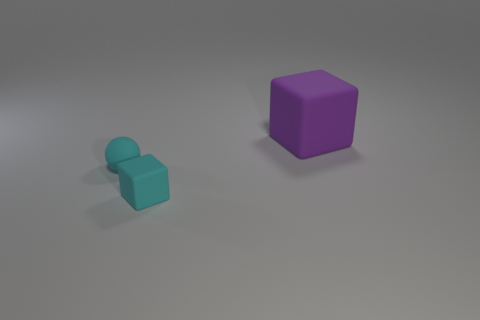There is a tiny cyan object that is the same shape as the purple rubber thing; what is it made of?
Make the answer very short. Rubber. There is a object that is the same color as the small cube; what material is it?
Offer a terse response. Rubber. Is the number of tiny cyan rubber balls less than the number of things?
Make the answer very short. Yes. Do the tiny rubber object that is to the left of the small cyan matte block and the tiny block have the same color?
Provide a succinct answer. Yes. What color is the ball that is the same material as the large purple object?
Offer a very short reply. Cyan. Do the cyan matte cube and the ball have the same size?
Your answer should be very brief. Yes. What is the material of the small sphere?
Your answer should be very brief. Rubber. What material is the cube that is the same size as the ball?
Keep it short and to the point. Rubber. Is there a sphere that has the same size as the cyan cube?
Your response must be concise. Yes. Are there the same number of objects that are left of the small sphere and cyan rubber balls that are on the right side of the big purple rubber thing?
Your answer should be very brief. Yes. 